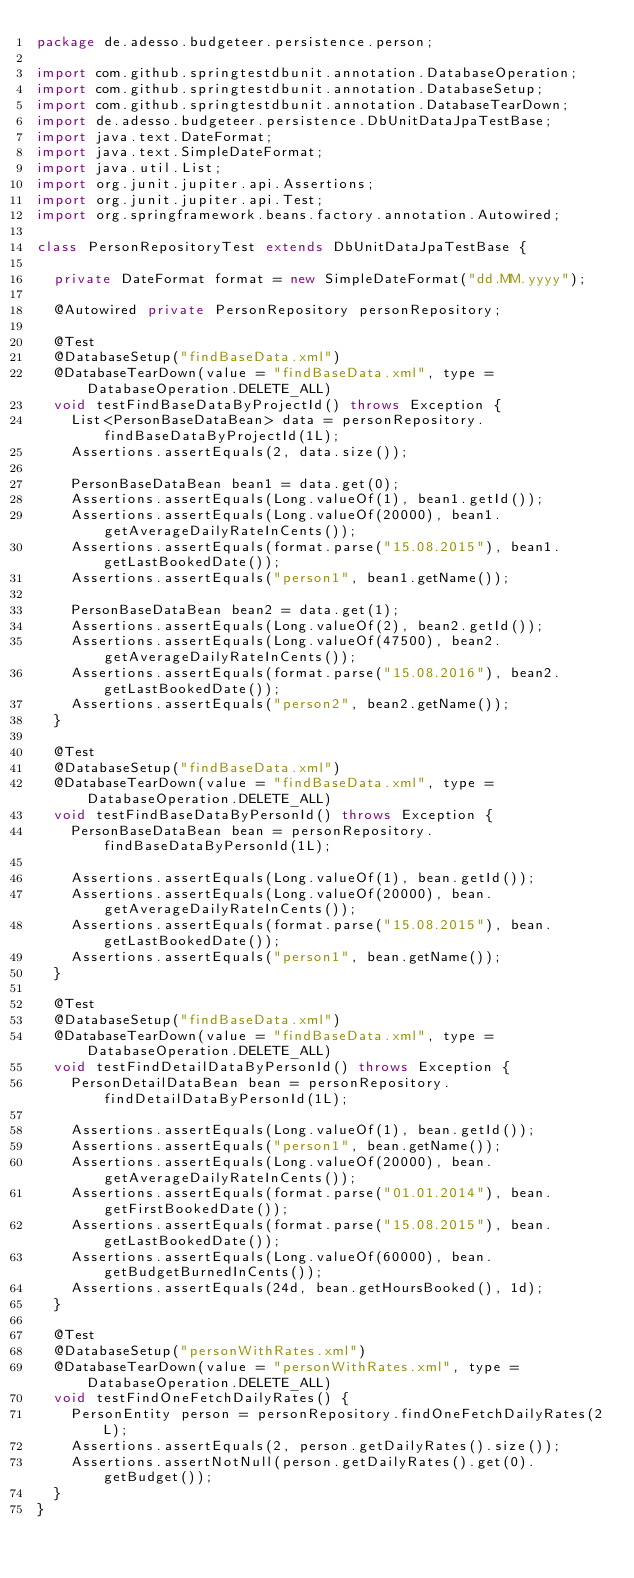<code> <loc_0><loc_0><loc_500><loc_500><_Java_>package de.adesso.budgeteer.persistence.person;

import com.github.springtestdbunit.annotation.DatabaseOperation;
import com.github.springtestdbunit.annotation.DatabaseSetup;
import com.github.springtestdbunit.annotation.DatabaseTearDown;
import de.adesso.budgeteer.persistence.DbUnitDataJpaTestBase;
import java.text.DateFormat;
import java.text.SimpleDateFormat;
import java.util.List;
import org.junit.jupiter.api.Assertions;
import org.junit.jupiter.api.Test;
import org.springframework.beans.factory.annotation.Autowired;

class PersonRepositoryTest extends DbUnitDataJpaTestBase {

  private DateFormat format = new SimpleDateFormat("dd.MM.yyyy");

  @Autowired private PersonRepository personRepository;

  @Test
  @DatabaseSetup("findBaseData.xml")
  @DatabaseTearDown(value = "findBaseData.xml", type = DatabaseOperation.DELETE_ALL)
  void testFindBaseDataByProjectId() throws Exception {
    List<PersonBaseDataBean> data = personRepository.findBaseDataByProjectId(1L);
    Assertions.assertEquals(2, data.size());

    PersonBaseDataBean bean1 = data.get(0);
    Assertions.assertEquals(Long.valueOf(1), bean1.getId());
    Assertions.assertEquals(Long.valueOf(20000), bean1.getAverageDailyRateInCents());
    Assertions.assertEquals(format.parse("15.08.2015"), bean1.getLastBookedDate());
    Assertions.assertEquals("person1", bean1.getName());

    PersonBaseDataBean bean2 = data.get(1);
    Assertions.assertEquals(Long.valueOf(2), bean2.getId());
    Assertions.assertEquals(Long.valueOf(47500), bean2.getAverageDailyRateInCents());
    Assertions.assertEquals(format.parse("15.08.2016"), bean2.getLastBookedDate());
    Assertions.assertEquals("person2", bean2.getName());
  }

  @Test
  @DatabaseSetup("findBaseData.xml")
  @DatabaseTearDown(value = "findBaseData.xml", type = DatabaseOperation.DELETE_ALL)
  void testFindBaseDataByPersonId() throws Exception {
    PersonBaseDataBean bean = personRepository.findBaseDataByPersonId(1L);

    Assertions.assertEquals(Long.valueOf(1), bean.getId());
    Assertions.assertEquals(Long.valueOf(20000), bean.getAverageDailyRateInCents());
    Assertions.assertEquals(format.parse("15.08.2015"), bean.getLastBookedDate());
    Assertions.assertEquals("person1", bean.getName());
  }

  @Test
  @DatabaseSetup("findBaseData.xml")
  @DatabaseTearDown(value = "findBaseData.xml", type = DatabaseOperation.DELETE_ALL)
  void testFindDetailDataByPersonId() throws Exception {
    PersonDetailDataBean bean = personRepository.findDetailDataByPersonId(1L);

    Assertions.assertEquals(Long.valueOf(1), bean.getId());
    Assertions.assertEquals("person1", bean.getName());
    Assertions.assertEquals(Long.valueOf(20000), bean.getAverageDailyRateInCents());
    Assertions.assertEquals(format.parse("01.01.2014"), bean.getFirstBookedDate());
    Assertions.assertEquals(format.parse("15.08.2015"), bean.getLastBookedDate());
    Assertions.assertEquals(Long.valueOf(60000), bean.getBudgetBurnedInCents());
    Assertions.assertEquals(24d, bean.getHoursBooked(), 1d);
  }

  @Test
  @DatabaseSetup("personWithRates.xml")
  @DatabaseTearDown(value = "personWithRates.xml", type = DatabaseOperation.DELETE_ALL)
  void testFindOneFetchDailyRates() {
    PersonEntity person = personRepository.findOneFetchDailyRates(2L);
    Assertions.assertEquals(2, person.getDailyRates().size());
    Assertions.assertNotNull(person.getDailyRates().get(0).getBudget());
  }
}
</code> 